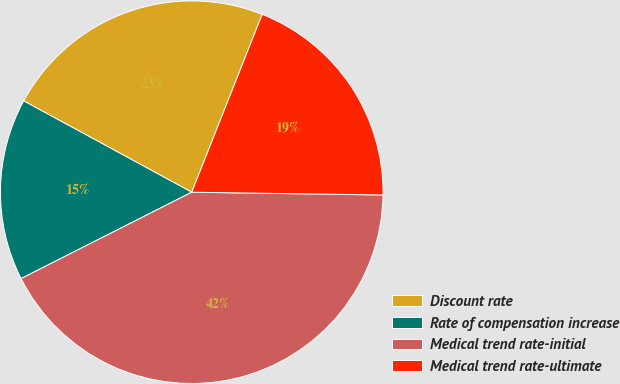<chart> <loc_0><loc_0><loc_500><loc_500><pie_chart><fcel>Discount rate<fcel>Rate of compensation increase<fcel>Medical trend rate-initial<fcel>Medical trend rate-ultimate<nl><fcel>23.08%<fcel>15.38%<fcel>42.31%<fcel>19.23%<nl></chart> 